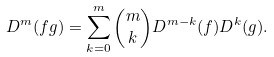Convert formula to latex. <formula><loc_0><loc_0><loc_500><loc_500>D ^ { m } ( f g ) = \sum _ { k = 0 } ^ { m } { \binom { m } { k } } D ^ { m - k } ( f ) D ^ { k } ( g ) .</formula> 